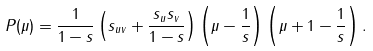<formula> <loc_0><loc_0><loc_500><loc_500>P ( \mu ) = \frac { 1 } { 1 - s } \left ( s _ { u v } + \frac { s _ { u } s _ { v } } { 1 - s } \right ) \left ( \mu - \frac { 1 } { s } \right ) \left ( \mu + 1 - \frac { 1 } { s } \right ) .</formula> 